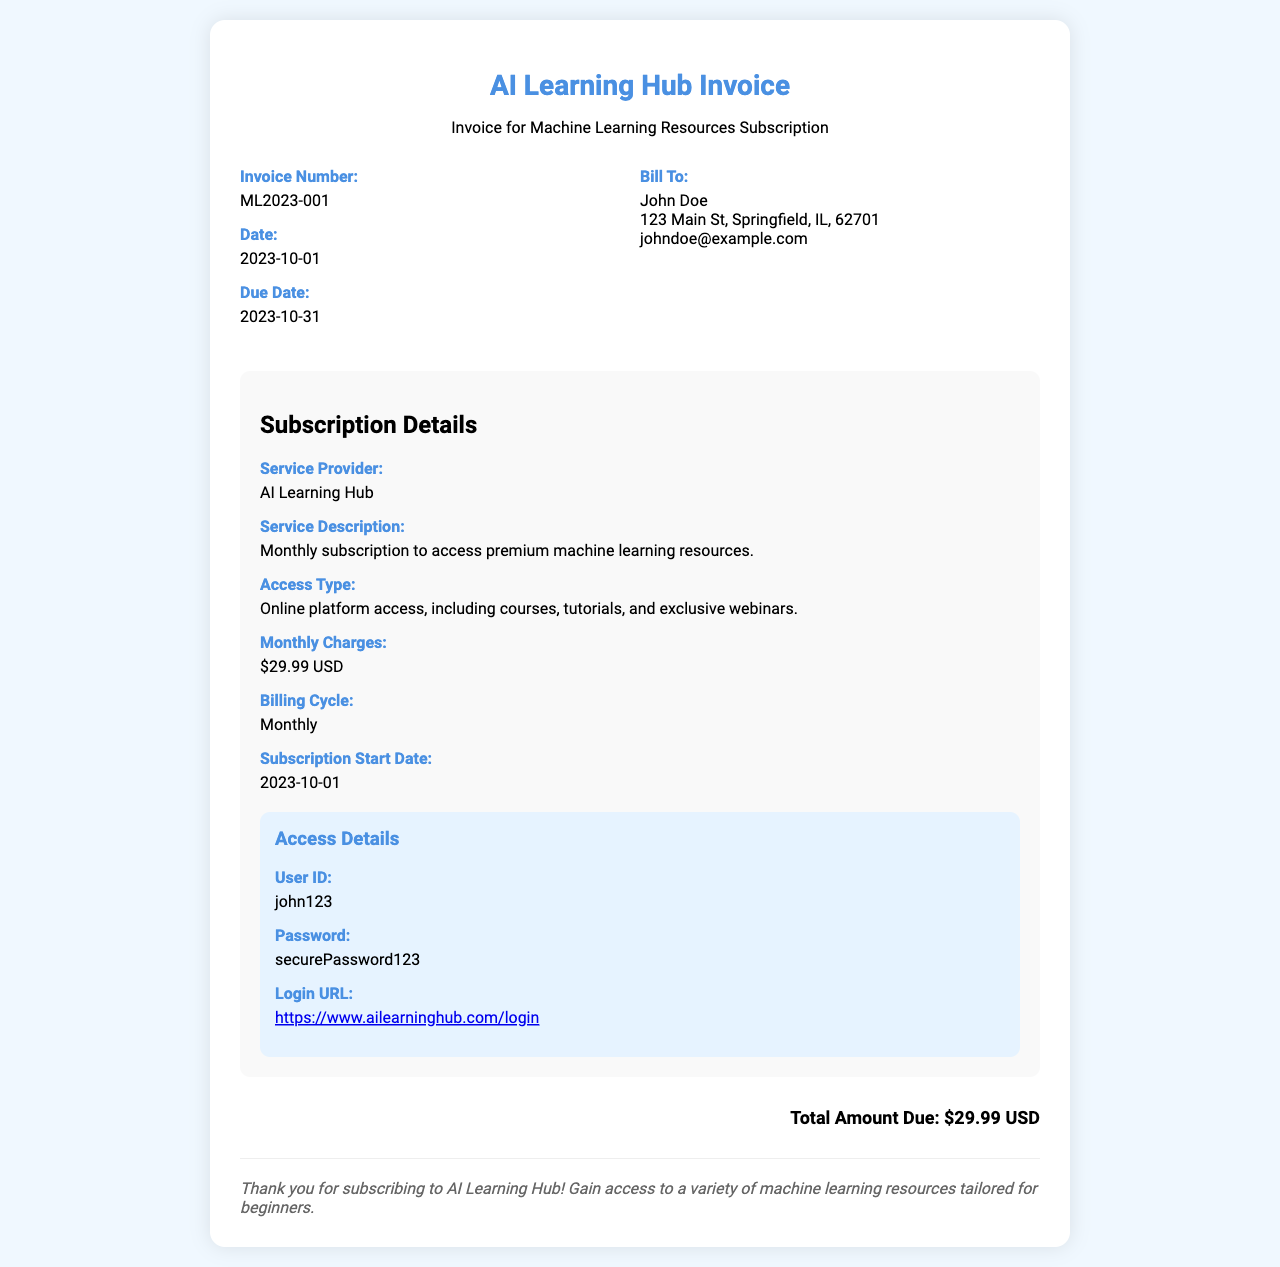What is the invoice number? The invoice number is stated in the document, which is a unique identifier for this transaction.
Answer: ML2023-001 What is the date of the invoice? The date of the invoice indicates when it was issued, found in the document.
Answer: 2023-10-01 What is the total amount due? The total amount due summarizes the financial obligation as detailed in the invoice.
Answer: $29.99 USD What is the service provider's name? The name of the company providing the service can be found in the subscription details section.
Answer: AI Learning Hub What is the billing cycle? The billing cycle specifies how often the charges are incurred for the subscription.
Answer: Monthly When does the subscription start? The subscription start date indicates when the service access begins as mentioned in the invoice.
Answer: 2023-10-01 What type of access does the subscription provide? The access type describes the resources available to users as outlined in the subscription details.
Answer: Online platform access, including courses, tutorials, and exclusive webinars How much is the monthly charge? The monthly charge is an important detail regarding the cost of the subscription, indicated in the invoice.
Answer: $29.99 USD What information is required to log in? The document includes user credentials essential for accessing the service platform.
Answer: User ID and Password 